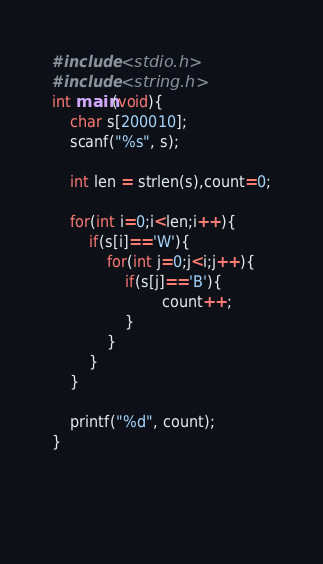Convert code to text. <code><loc_0><loc_0><loc_500><loc_500><_C_>#include <stdio.h>
#include <string.h>
int main(void){
	char s[200010];
  	scanf("%s", s);
  
  	int len = strlen(s),count=0;
  
  	for(int i=0;i<len;i++){
     	if(s[i]=='W'){
          	for(int j=0;j<i;j++){
				if(s[j]=='B'){
						count++;
                }
            }
        }
    }

  	printf("%d", count);
}
      
		
  	</code> 